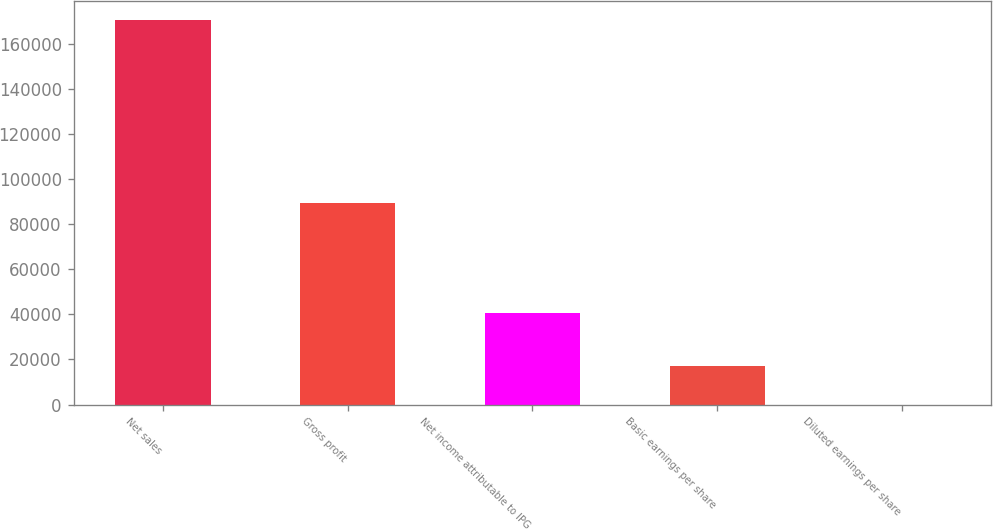Convert chart. <chart><loc_0><loc_0><loc_500><loc_500><bar_chart><fcel>Net sales<fcel>Gross profit<fcel>Net income attributable to IPG<fcel>Basic earnings per share<fcel>Diluted earnings per share<nl><fcel>170575<fcel>89284<fcel>40531<fcel>17058.2<fcel>0.77<nl></chart> 